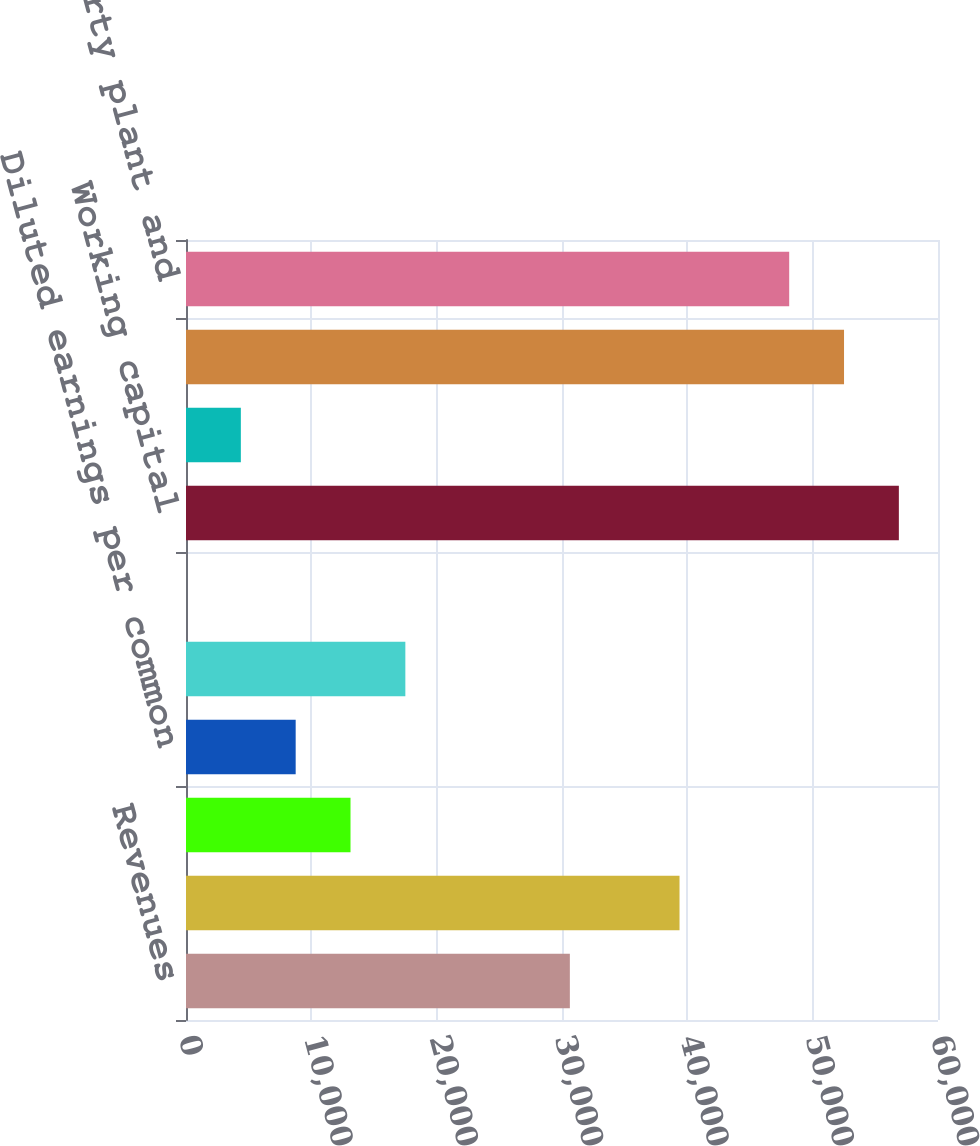<chart> <loc_0><loc_0><loc_500><loc_500><bar_chart><fcel>Revenues<fcel>Depreciation Net earnings<fcel>Basic earnings per common<fcel>Diluted earnings per common<fcel>Cash dividends<fcel>Per common share<fcel>Working capital<fcel>Current ratio<fcel>Inventories<fcel>Net property plant and<nl><fcel>30626.6<fcel>39376.8<fcel>13126.1<fcel>8751<fcel>17501.2<fcel>0.76<fcel>56877.3<fcel>4375.88<fcel>52502.2<fcel>48127.1<nl></chart> 